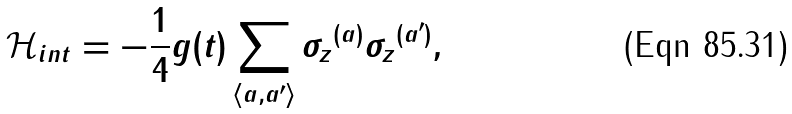<formula> <loc_0><loc_0><loc_500><loc_500>\mathcal { H } _ { i n t } = - \frac { 1 } { 4 } g ( t ) \sum _ { \langle a , a ^ { \prime } \rangle } { \sigma _ { z } } ^ { ( a ) } { \sigma _ { z } } ^ { ( a ^ { \prime } ) } ,</formula> 